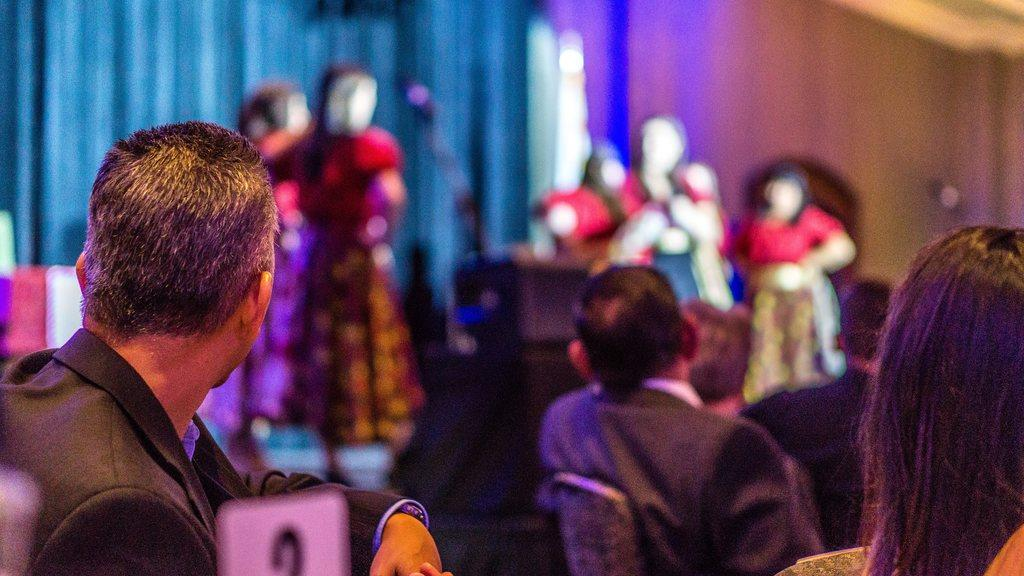How many people are in the image? There are people in the image, but the exact number is not specified. What are some of the people doing in the image? Some people are sitting on chairs, while others are standing. Can you describe the background of the image? The background of the image is blurred. What type of curtain can be seen hanging from the ceiling in the image? There is no curtain present in the image. 